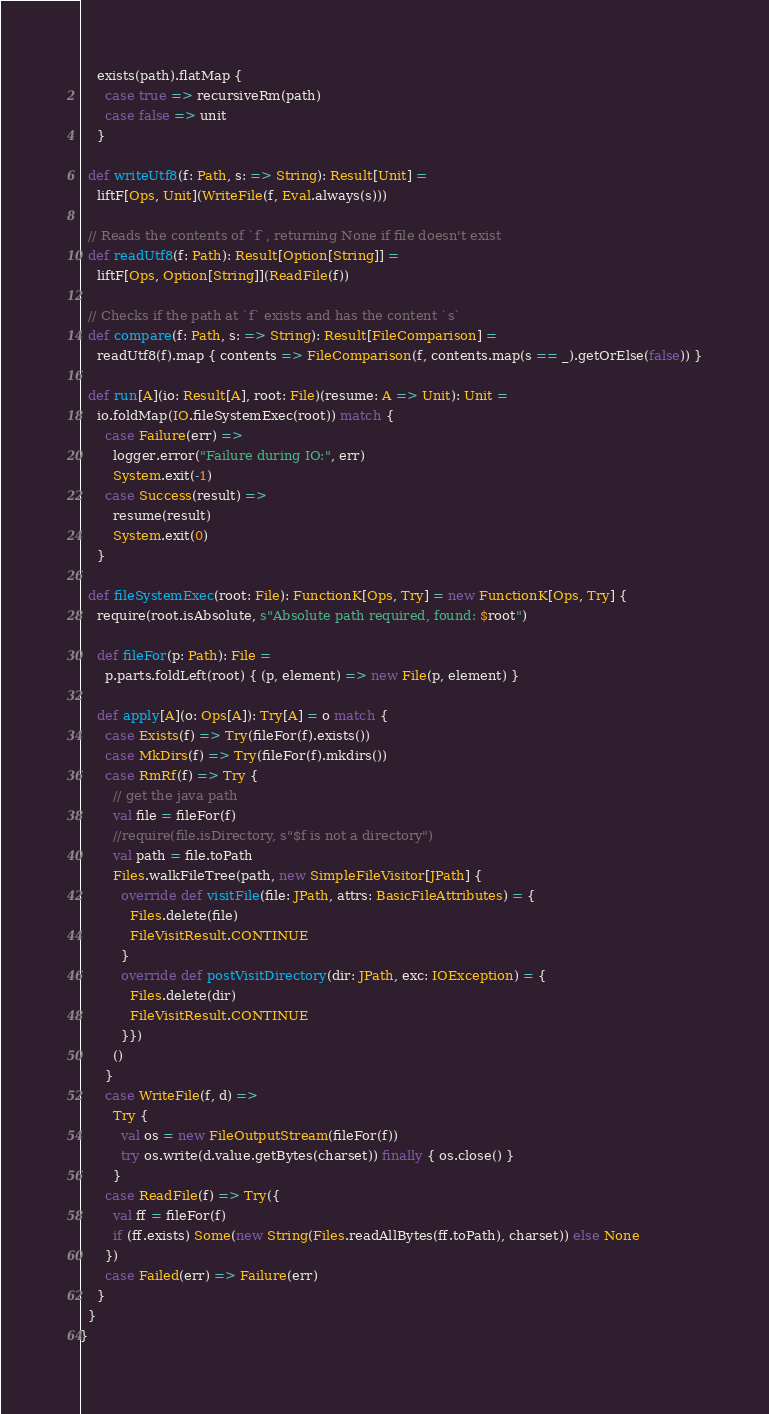<code> <loc_0><loc_0><loc_500><loc_500><_Scala_>    exists(path).flatMap {
      case true => recursiveRm(path)
      case false => unit
    }

  def writeUtf8(f: Path, s: => String): Result[Unit] =
    liftF[Ops, Unit](WriteFile(f, Eval.always(s)))

  // Reads the contents of `f`, returning None if file doesn't exist
  def readUtf8(f: Path): Result[Option[String]] =
    liftF[Ops, Option[String]](ReadFile(f))

  // Checks if the path at `f` exists and has the content `s`
  def compare(f: Path, s: => String): Result[FileComparison] =
    readUtf8(f).map { contents => FileComparison(f, contents.map(s == _).getOrElse(false)) }

  def run[A](io: Result[A], root: File)(resume: A => Unit): Unit =
    io.foldMap(IO.fileSystemExec(root)) match {
      case Failure(err) =>
        logger.error("Failure during IO:", err)
        System.exit(-1)
      case Success(result) =>
        resume(result)
        System.exit(0)
    }

  def fileSystemExec(root: File): FunctionK[Ops, Try] = new FunctionK[Ops, Try] {
    require(root.isAbsolute, s"Absolute path required, found: $root")

    def fileFor(p: Path): File =
      p.parts.foldLeft(root) { (p, element) => new File(p, element) }

    def apply[A](o: Ops[A]): Try[A] = o match {
      case Exists(f) => Try(fileFor(f).exists())
      case MkDirs(f) => Try(fileFor(f).mkdirs())
      case RmRf(f) => Try {
        // get the java path
        val file = fileFor(f)
        //require(file.isDirectory, s"$f is not a directory")
        val path = file.toPath
        Files.walkFileTree(path, new SimpleFileVisitor[JPath] {
          override def visitFile(file: JPath, attrs: BasicFileAttributes) = {
            Files.delete(file)
            FileVisitResult.CONTINUE
          }
          override def postVisitDirectory(dir: JPath, exc: IOException) = {
            Files.delete(dir)
            FileVisitResult.CONTINUE
          }})
        ()
      }
      case WriteFile(f, d) =>
        Try {
          val os = new FileOutputStream(fileFor(f))
          try os.write(d.value.getBytes(charset)) finally { os.close() }
        }
      case ReadFile(f) => Try({
        val ff = fileFor(f)
        if (ff.exists) Some(new String(Files.readAllBytes(ff.toPath), charset)) else None
      })
      case Failed(err) => Failure(err)
    }
  }
}
</code> 